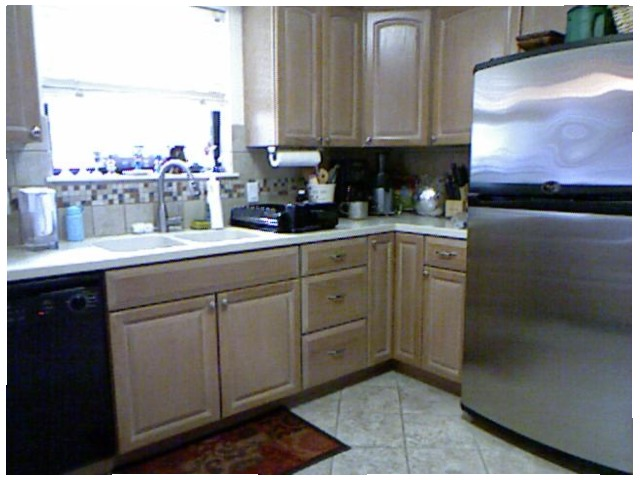<image>
Is there a sink in front of the paper towels? No. The sink is not in front of the paper towels. The spatial positioning shows a different relationship between these objects. 